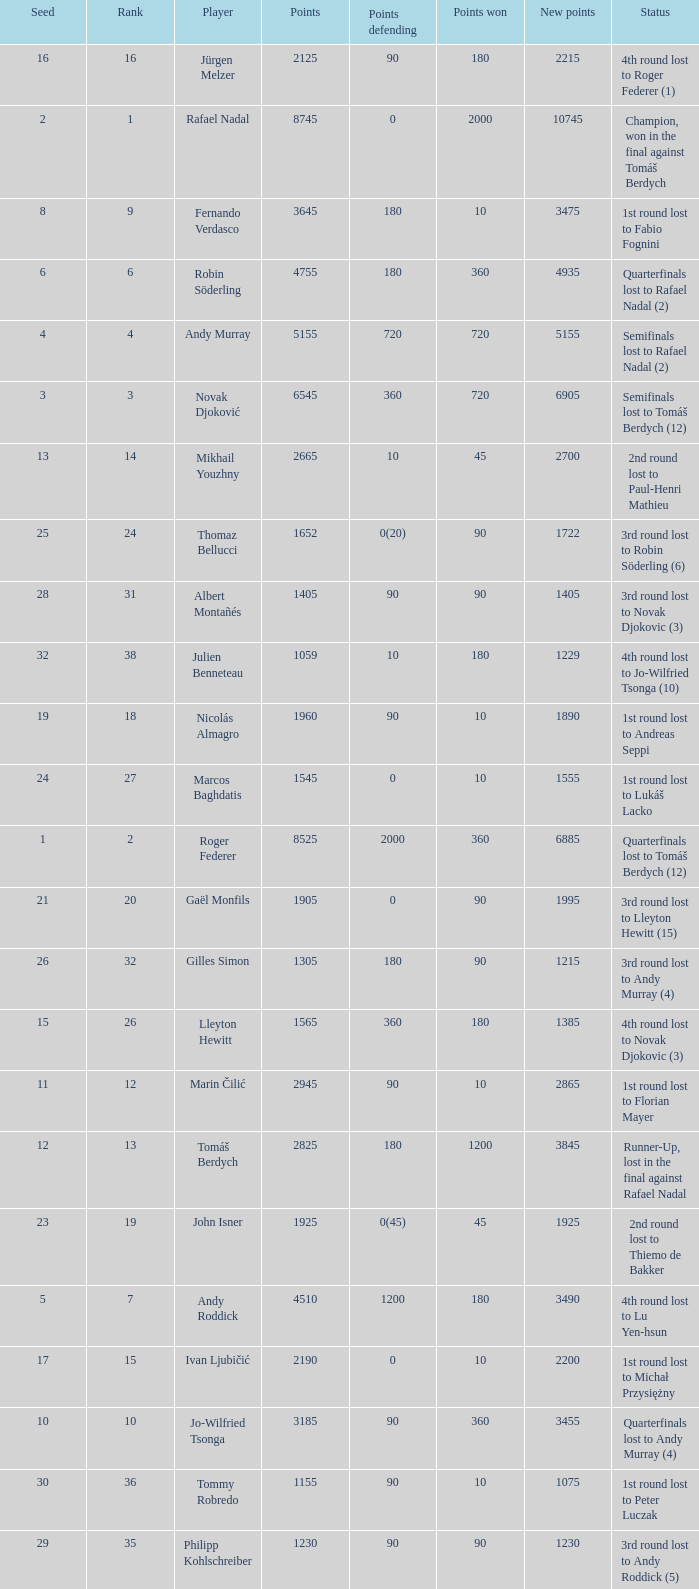Parse the table in full. {'header': ['Seed', 'Rank', 'Player', 'Points', 'Points defending', 'Points won', 'New points', 'Status'], 'rows': [['16', '16', 'Jürgen Melzer', '2125', '90', '180', '2215', '4th round lost to Roger Federer (1)'], ['2', '1', 'Rafael Nadal', '8745', '0', '2000', '10745', 'Champion, won in the final against Tomáš Berdych'], ['8', '9', 'Fernando Verdasco', '3645', '180', '10', '3475', '1st round lost to Fabio Fognini'], ['6', '6', 'Robin Söderling', '4755', '180', '360', '4935', 'Quarterfinals lost to Rafael Nadal (2)'], ['4', '4', 'Andy Murray', '5155', '720', '720', '5155', 'Semifinals lost to Rafael Nadal (2)'], ['3', '3', 'Novak Djoković', '6545', '360', '720', '6905', 'Semifinals lost to Tomáš Berdych (12)'], ['13', '14', 'Mikhail Youzhny', '2665', '10', '45', '2700', '2nd round lost to Paul-Henri Mathieu'], ['25', '24', 'Thomaz Bellucci', '1652', '0(20)', '90', '1722', '3rd round lost to Robin Söderling (6)'], ['28', '31', 'Albert Montañés', '1405', '90', '90', '1405', '3rd round lost to Novak Djokovic (3)'], ['32', '38', 'Julien Benneteau', '1059', '10', '180', '1229', '4th round lost to Jo-Wilfried Tsonga (10)'], ['19', '18', 'Nicolás Almagro', '1960', '90', '10', '1890', '1st round lost to Andreas Seppi'], ['24', '27', 'Marcos Baghdatis', '1545', '0', '10', '1555', '1st round lost to Lukáš Lacko'], ['1', '2', 'Roger Federer', '8525', '2000', '360', '6885', 'Quarterfinals lost to Tomáš Berdych (12)'], ['21', '20', 'Gaël Monfils', '1905', '0', '90', '1995', '3rd round lost to Lleyton Hewitt (15)'], ['26', '32', 'Gilles Simon', '1305', '180', '90', '1215', '3rd round lost to Andy Murray (4)'], ['15', '26', 'Lleyton Hewitt', '1565', '360', '180', '1385', '4th round lost to Novak Djokovic (3)'], ['11', '12', 'Marin Čilić', '2945', '90', '10', '2865', '1st round lost to Florian Mayer'], ['12', '13', 'Tomáš Berdych', '2825', '180', '1200', '3845', 'Runner-Up, lost in the final against Rafael Nadal'], ['23', '19', 'John Isner', '1925', '0(45)', '45', '1925', '2nd round lost to Thiemo de Bakker'], ['5', '7', 'Andy Roddick', '4510', '1200', '180', '3490', '4th round lost to Lu Yen-hsun'], ['17', '15', 'Ivan Ljubičić', '2190', '0', '10', '2200', '1st round lost to Michał Przysiężny'], ['10', '10', 'Jo-Wilfried Tsonga', '3185', '90', '360', '3455', 'Quarterfinals lost to Andy Murray (4)'], ['30', '36', 'Tommy Robredo', '1155', '90', '10', '1075', '1st round lost to Peter Luczak'], ['29', '35', 'Philipp Kohlschreiber', '1230', '90', '90', '1230', '3rd round lost to Andy Roddick (5)'], ['14', '17', 'Juan Carlos Ferrero', '2095', '360', '10', '1745', '1st round lost to Xavier Malisse'], ['7', '5', 'Nikolay Davydenko', '4785', '90', '45', '4740', '2nd round lost to Daniel Brands'], ['20', '23', 'Stanislas Wawrinka', '1690', '180', '10', '1520', '1st round lost to Denis Istomin'], ['22', '30', 'Feliciano López', '1455', '10', '90', '1535', '3rd round lost to Jürgen Melzer (16)'], ['9', '11', 'David Ferrer', '3010', '90', '180', '3100', '4th round lost to Robin Söderling (6)'], ['31', '37', 'Victor Hănescu', '1070', '45', '90', '1115', '3rd round lost to Daniel Brands'], ['18', '21', 'Sam Querrey', '1755', '45', '180', '1890', '4th round lost to Andy Murray (4)']]} Name the number of points defending for 1075 1.0. 